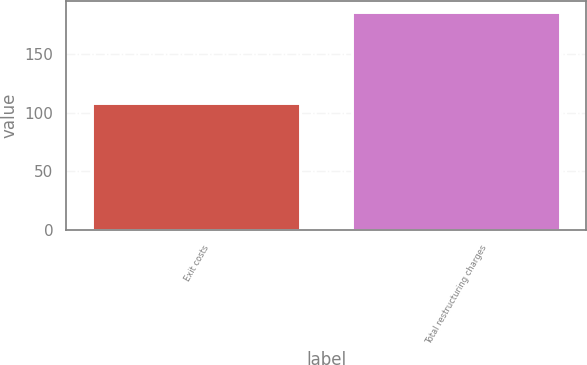Convert chart. <chart><loc_0><loc_0><loc_500><loc_500><bar_chart><fcel>Exit costs<fcel>Total restructuring charges<nl><fcel>108<fcel>186<nl></chart> 